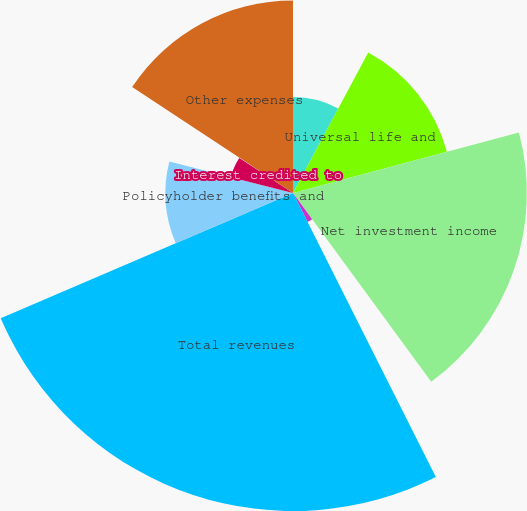Convert chart to OTSL. <chart><loc_0><loc_0><loc_500><loc_500><pie_chart><fcel>Premiums<fcel>Universal life and<fcel>Net investment income<fcel>Other revenues<fcel>Total revenues<fcel>Policyholder benefits and<fcel>Interest credited to<fcel>Amortization of DAC and VOBA<fcel>Other expenses<nl><fcel>7.83%<fcel>13.01%<fcel>19.1%<fcel>2.65%<fcel>25.97%<fcel>10.42%<fcel>5.24%<fcel>0.06%<fcel>15.73%<nl></chart> 